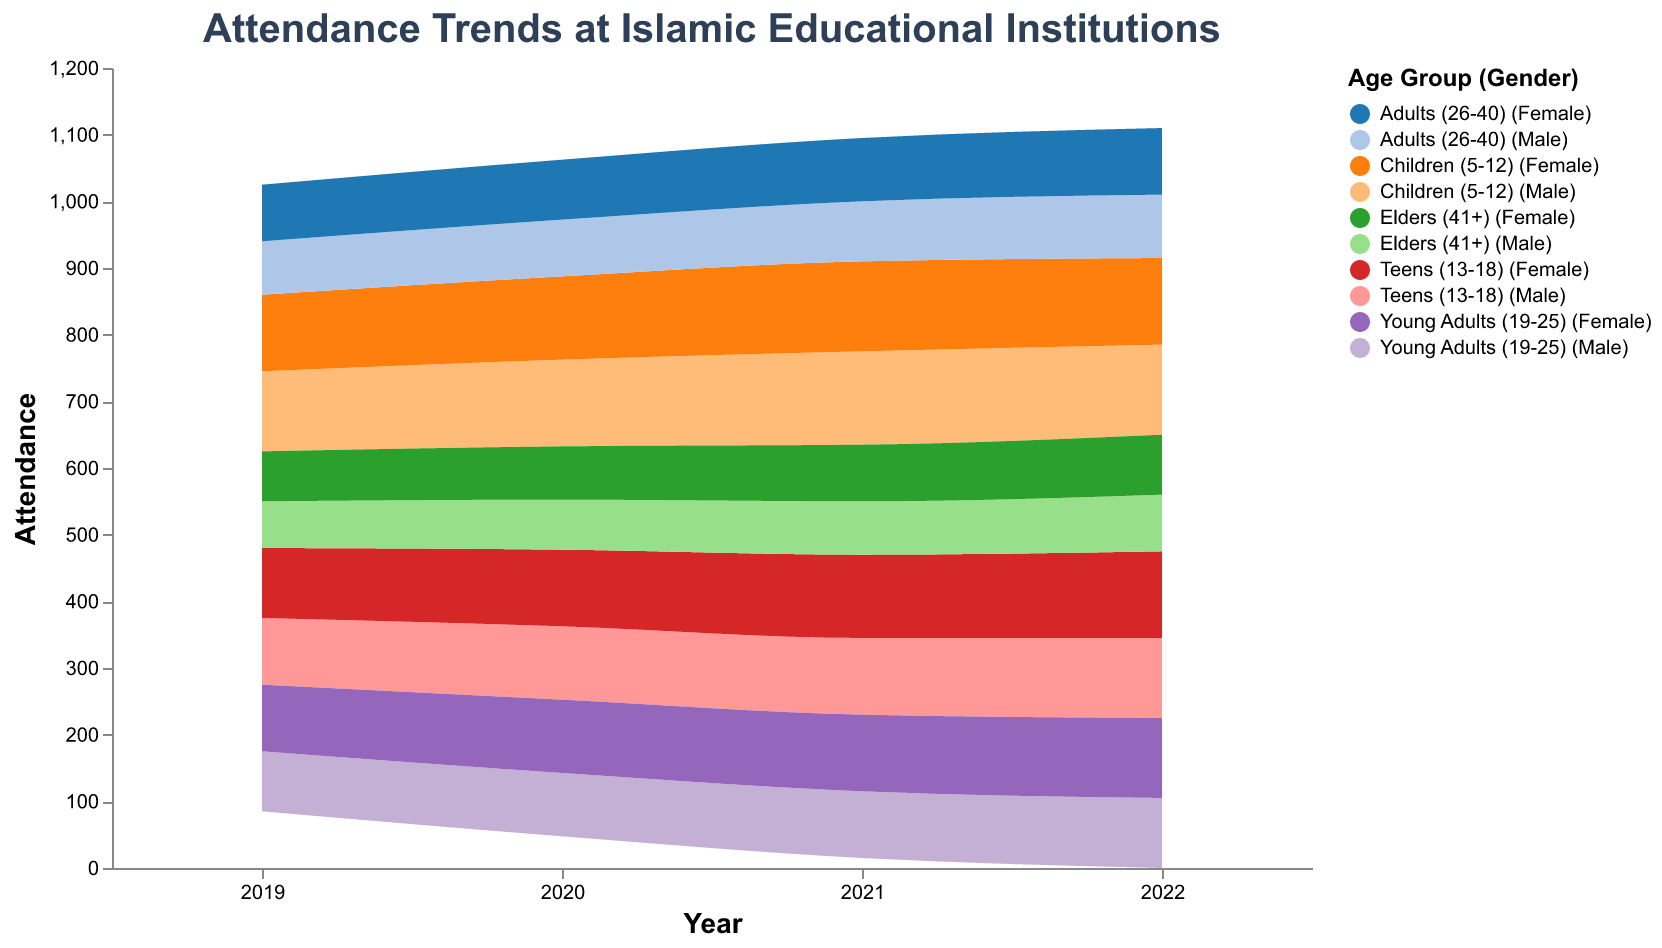What is the title of the figure? The title is at the top of the figure and reads: "Attendance Trends at Islamic Educational Institutions".
Answer: Attendance Trends at Islamic Educational Institutions Which age group and gender combination has the highest attendance in 2022? By examining each segment for 2022, we see that "Teens (13-18) Female" has the highest attendance with a value of 130.
Answer: Teens (13-18) Female How did the attendance for Elders (41+) Male change from 2019 to 2022? Attendance for Elders (41+) Male increased gradually from 70 in 2019 to 85 in 2022, with increments each year: 70 (2019), 75 (2020), 80 (2021), and 85 (2022).
Answer: Increased from 70 to 85 Which age group shows a steady increase in attendance across all years for both genders? Both "Teens (13-18)" and "Young Adults (19-25)" show steady increases in attendance each year for both male and female genders.
Answer: Teens (13-18) and Young Adults (19-25) Compare the attendance trends of Children (5-12) for both genders in 2021. Which gender has a higher attendance? In 2021, "Children (5-12) Male" has an attendance of 140 while "Children (5-12) Female" has 135. Therefore, males have slightly higher attendance.
Answer: Male What is the overall trend of attendance for Young Adults (19-25) Male from 2019 to 2022? The attendance for Young Adults (19-25) Male shows a gradual increase from 90 in 2019 to 105 in 2022.
Answer: Gradually increasing In which year did Adults (26-40) Female surpass the attendance of Adults (26-40) Male? In 2019, Adults (26-40) Female had an attendance of 85, same as Adults (26-40) Male. From 2020 onwards, the attendance for females surpasses that of males each year.
Answer: 2020 What is the change in attendance for Teens (13-18) Female from 2019 to 2022? In 2019, the attendance is 105, and it increases to 130 in 2022. The change is 130 - 105 = 25.
Answer: Increased by 25 Which gender has a higher attendance in 2022 for each age group? By checking each age group for the year 2022: Children (5-12) Male: 135, Female: 130; Teens (13-18) Male: 120, Female: 130; Young Adults (19-25) Male: 105, Female: 120; Adults (26-40) Male: 95, Female: 100; Elders (41+) Male: 85, Female: 90.
Answer: Children: Male; Teens: Female; Young Adults: Female; Adults: Female; Elders: Female How is the overall attendance trend for the Children (5-12) group from 2019 to 2022? For both genders, the attendance increases from 2019 to 2021 and then shows a slight decrease in 2022.
Answer: Increasing then slightly decreasing 